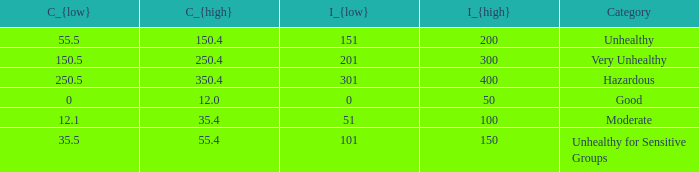What's the C_{low} value when C_{high} is 12.0? 0.0. 